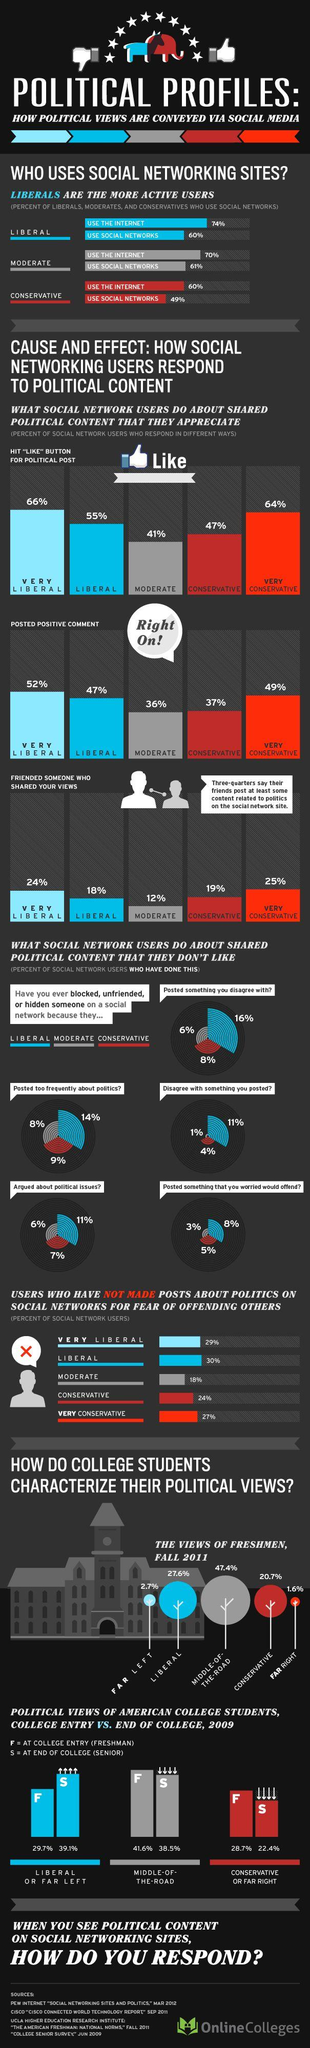Mention a couple of crucial points in this snapshot. A 6.3% decrease in the percentage of seniors with far-right political views was observed from the time they joined college. A recent study revealed that a group of conservatives posted 37% of the positive comments on social media. According to a survey, 47.4% of college students have chosen to express their political views, indicating a moderate approach. According to a recent survey, 39.1% of college seniors have far left political ideology. According to the given data, 18% of Liberals had friends who shared their political views. 